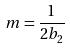<formula> <loc_0><loc_0><loc_500><loc_500>m = \frac { 1 } { 2 b _ { 2 } }</formula> 